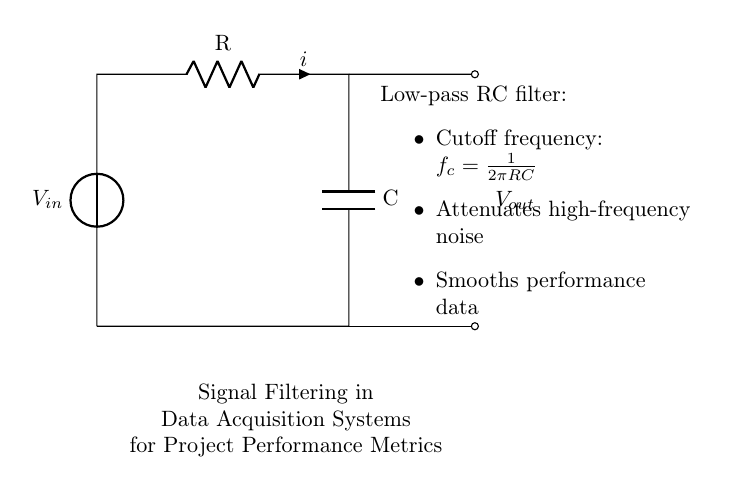What are the components in this circuit? The circuit contains a voltage source, a resistor, and a capacitor, which are all standard components in a resistor-capacitor circuit.
Answer: voltage source, resistor, capacitor What is the relationship between the resistor and capacitor in this circuit? The resistor and capacitor are connected in series, creating an RC circuit that influences how signals are filtered based on their frequencies.
Answer: series connection What is the cutoff frequency of the filter? The cutoff frequency is calculated as one over two pi multiplied by the resistance and capacitance, using the formula fc = 1/(2πRC).
Answer: fc = 1/(2πRC) How does this circuit affect high-frequency signals? This low-pass RC filter attenuates high-frequency signals, effectively reducing noise in the output voltage for more reliable data acquisition.
Answer: attenuates What is the output signal's behavior as frequency increases? As frequency increases beyond the cutoff frequency, the output signal will decrease in amplitude, demonstrating the filtering effect of the circuit.
Answer: decreases in amplitude What type of filter is represented by this circuit? The circuit represents a low-pass filter, which allows signals below a certain frequency to pass while attenuating higher frequencies.
Answer: low-pass filter 